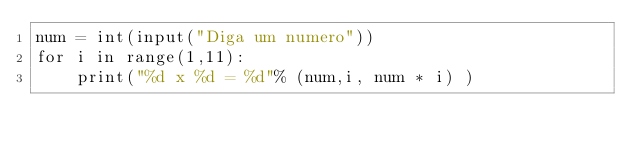<code> <loc_0><loc_0><loc_500><loc_500><_Python_>num = int(input("Diga um numero"))
for i in range(1,11):
    print("%d x %d = %d"% (num,i, num * i) )</code> 